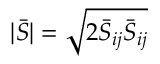<formula> <loc_0><loc_0><loc_500><loc_500>| \bar { S } | = \sqrt { 2 \bar { S } _ { i j } \bar { S } _ { i j } }</formula> 